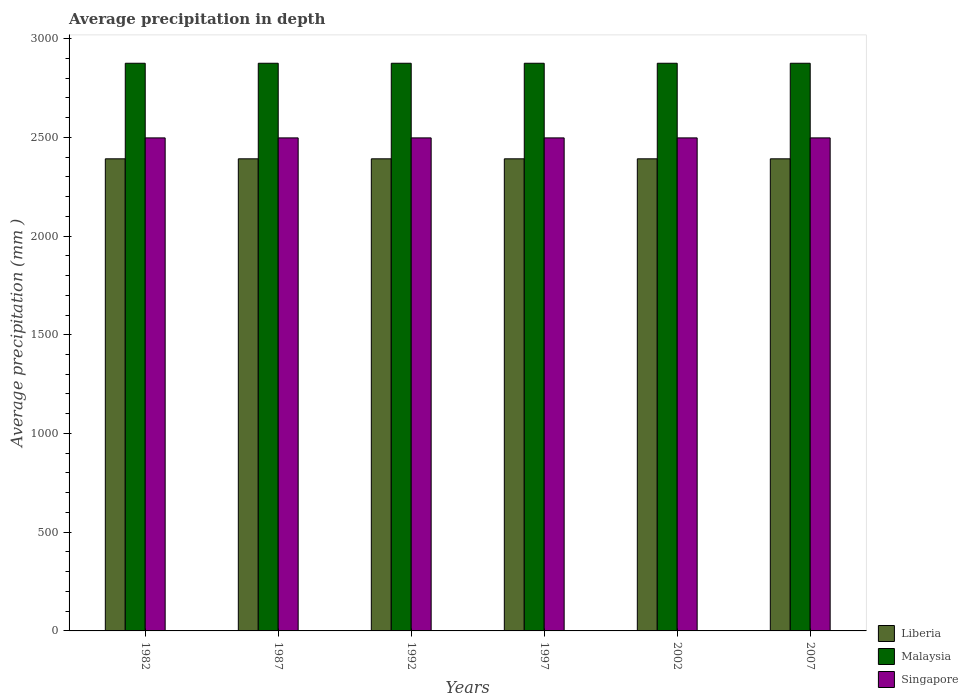How many bars are there on the 2nd tick from the left?
Your response must be concise. 3. What is the label of the 2nd group of bars from the left?
Keep it short and to the point. 1987. What is the average precipitation in Singapore in 2002?
Keep it short and to the point. 2497. Across all years, what is the maximum average precipitation in Malaysia?
Your answer should be compact. 2875. Across all years, what is the minimum average precipitation in Liberia?
Make the answer very short. 2391. In which year was the average precipitation in Singapore maximum?
Provide a short and direct response. 1982. In which year was the average precipitation in Malaysia minimum?
Offer a very short reply. 1982. What is the total average precipitation in Singapore in the graph?
Give a very brief answer. 1.50e+04. What is the difference between the average precipitation in Malaysia in 1982 and that in 1992?
Your response must be concise. 0. What is the difference between the average precipitation in Singapore in 1997 and the average precipitation in Liberia in 2002?
Ensure brevity in your answer.  106. What is the average average precipitation in Malaysia per year?
Ensure brevity in your answer.  2875. In the year 1982, what is the difference between the average precipitation in Singapore and average precipitation in Liberia?
Offer a very short reply. 106. What is the difference between the highest and the second highest average precipitation in Liberia?
Provide a short and direct response. 0. What is the difference between the highest and the lowest average precipitation in Singapore?
Your answer should be compact. 0. In how many years, is the average precipitation in Malaysia greater than the average average precipitation in Malaysia taken over all years?
Your answer should be compact. 0. Is the sum of the average precipitation in Singapore in 1987 and 2002 greater than the maximum average precipitation in Malaysia across all years?
Make the answer very short. Yes. What does the 2nd bar from the left in 1992 represents?
Your answer should be compact. Malaysia. What does the 3rd bar from the right in 1987 represents?
Ensure brevity in your answer.  Liberia. Is it the case that in every year, the sum of the average precipitation in Liberia and average precipitation in Singapore is greater than the average precipitation in Malaysia?
Keep it short and to the point. Yes. How many bars are there?
Make the answer very short. 18. Are all the bars in the graph horizontal?
Provide a short and direct response. No. How many years are there in the graph?
Your answer should be very brief. 6. What is the difference between two consecutive major ticks on the Y-axis?
Offer a terse response. 500. What is the title of the graph?
Your response must be concise. Average precipitation in depth. What is the label or title of the X-axis?
Provide a short and direct response. Years. What is the label or title of the Y-axis?
Offer a terse response. Average precipitation (mm ). What is the Average precipitation (mm ) of Liberia in 1982?
Your answer should be compact. 2391. What is the Average precipitation (mm ) in Malaysia in 1982?
Ensure brevity in your answer.  2875. What is the Average precipitation (mm ) in Singapore in 1982?
Ensure brevity in your answer.  2497. What is the Average precipitation (mm ) of Liberia in 1987?
Offer a terse response. 2391. What is the Average precipitation (mm ) of Malaysia in 1987?
Offer a terse response. 2875. What is the Average precipitation (mm ) in Singapore in 1987?
Give a very brief answer. 2497. What is the Average precipitation (mm ) in Liberia in 1992?
Offer a terse response. 2391. What is the Average precipitation (mm ) of Malaysia in 1992?
Your answer should be compact. 2875. What is the Average precipitation (mm ) in Singapore in 1992?
Offer a terse response. 2497. What is the Average precipitation (mm ) of Liberia in 1997?
Make the answer very short. 2391. What is the Average precipitation (mm ) of Malaysia in 1997?
Make the answer very short. 2875. What is the Average precipitation (mm ) in Singapore in 1997?
Offer a very short reply. 2497. What is the Average precipitation (mm ) in Liberia in 2002?
Provide a succinct answer. 2391. What is the Average precipitation (mm ) of Malaysia in 2002?
Your answer should be compact. 2875. What is the Average precipitation (mm ) of Singapore in 2002?
Ensure brevity in your answer.  2497. What is the Average precipitation (mm ) of Liberia in 2007?
Provide a succinct answer. 2391. What is the Average precipitation (mm ) of Malaysia in 2007?
Your answer should be very brief. 2875. What is the Average precipitation (mm ) of Singapore in 2007?
Make the answer very short. 2497. Across all years, what is the maximum Average precipitation (mm ) of Liberia?
Your response must be concise. 2391. Across all years, what is the maximum Average precipitation (mm ) of Malaysia?
Make the answer very short. 2875. Across all years, what is the maximum Average precipitation (mm ) of Singapore?
Your answer should be very brief. 2497. Across all years, what is the minimum Average precipitation (mm ) in Liberia?
Keep it short and to the point. 2391. Across all years, what is the minimum Average precipitation (mm ) of Malaysia?
Your answer should be compact. 2875. Across all years, what is the minimum Average precipitation (mm ) of Singapore?
Offer a terse response. 2497. What is the total Average precipitation (mm ) in Liberia in the graph?
Your answer should be very brief. 1.43e+04. What is the total Average precipitation (mm ) of Malaysia in the graph?
Your answer should be very brief. 1.72e+04. What is the total Average precipitation (mm ) of Singapore in the graph?
Your response must be concise. 1.50e+04. What is the difference between the Average precipitation (mm ) in Liberia in 1982 and that in 1987?
Keep it short and to the point. 0. What is the difference between the Average precipitation (mm ) of Malaysia in 1982 and that in 1987?
Your answer should be very brief. 0. What is the difference between the Average precipitation (mm ) in Singapore in 1982 and that in 1987?
Your answer should be compact. 0. What is the difference between the Average precipitation (mm ) of Malaysia in 1982 and that in 1992?
Keep it short and to the point. 0. What is the difference between the Average precipitation (mm ) in Liberia in 1982 and that in 1997?
Provide a short and direct response. 0. What is the difference between the Average precipitation (mm ) in Singapore in 1982 and that in 1997?
Make the answer very short. 0. What is the difference between the Average precipitation (mm ) of Liberia in 1982 and that in 2002?
Ensure brevity in your answer.  0. What is the difference between the Average precipitation (mm ) in Liberia in 1982 and that in 2007?
Make the answer very short. 0. What is the difference between the Average precipitation (mm ) of Malaysia in 1982 and that in 2007?
Your answer should be compact. 0. What is the difference between the Average precipitation (mm ) in Singapore in 1982 and that in 2007?
Your response must be concise. 0. What is the difference between the Average precipitation (mm ) in Singapore in 1987 and that in 1992?
Keep it short and to the point. 0. What is the difference between the Average precipitation (mm ) of Liberia in 1987 and that in 1997?
Offer a terse response. 0. What is the difference between the Average precipitation (mm ) in Malaysia in 1987 and that in 1997?
Provide a succinct answer. 0. What is the difference between the Average precipitation (mm ) of Liberia in 1987 and that in 2002?
Your answer should be very brief. 0. What is the difference between the Average precipitation (mm ) of Singapore in 1987 and that in 2002?
Provide a short and direct response. 0. What is the difference between the Average precipitation (mm ) of Singapore in 1987 and that in 2007?
Your response must be concise. 0. What is the difference between the Average precipitation (mm ) in Malaysia in 1992 and that in 1997?
Keep it short and to the point. 0. What is the difference between the Average precipitation (mm ) in Singapore in 1992 and that in 1997?
Give a very brief answer. 0. What is the difference between the Average precipitation (mm ) in Liberia in 1992 and that in 2002?
Offer a very short reply. 0. What is the difference between the Average precipitation (mm ) in Singapore in 1992 and that in 2002?
Your response must be concise. 0. What is the difference between the Average precipitation (mm ) in Singapore in 1997 and that in 2002?
Provide a short and direct response. 0. What is the difference between the Average precipitation (mm ) in Malaysia in 1997 and that in 2007?
Give a very brief answer. 0. What is the difference between the Average precipitation (mm ) in Singapore in 1997 and that in 2007?
Offer a terse response. 0. What is the difference between the Average precipitation (mm ) of Malaysia in 2002 and that in 2007?
Your response must be concise. 0. What is the difference between the Average precipitation (mm ) of Singapore in 2002 and that in 2007?
Ensure brevity in your answer.  0. What is the difference between the Average precipitation (mm ) of Liberia in 1982 and the Average precipitation (mm ) of Malaysia in 1987?
Keep it short and to the point. -484. What is the difference between the Average precipitation (mm ) of Liberia in 1982 and the Average precipitation (mm ) of Singapore in 1987?
Offer a very short reply. -106. What is the difference between the Average precipitation (mm ) of Malaysia in 1982 and the Average precipitation (mm ) of Singapore in 1987?
Provide a succinct answer. 378. What is the difference between the Average precipitation (mm ) in Liberia in 1982 and the Average precipitation (mm ) in Malaysia in 1992?
Keep it short and to the point. -484. What is the difference between the Average precipitation (mm ) in Liberia in 1982 and the Average precipitation (mm ) in Singapore in 1992?
Ensure brevity in your answer.  -106. What is the difference between the Average precipitation (mm ) of Malaysia in 1982 and the Average precipitation (mm ) of Singapore in 1992?
Your answer should be compact. 378. What is the difference between the Average precipitation (mm ) in Liberia in 1982 and the Average precipitation (mm ) in Malaysia in 1997?
Make the answer very short. -484. What is the difference between the Average precipitation (mm ) in Liberia in 1982 and the Average precipitation (mm ) in Singapore in 1997?
Your answer should be very brief. -106. What is the difference between the Average precipitation (mm ) of Malaysia in 1982 and the Average precipitation (mm ) of Singapore in 1997?
Make the answer very short. 378. What is the difference between the Average precipitation (mm ) in Liberia in 1982 and the Average precipitation (mm ) in Malaysia in 2002?
Your response must be concise. -484. What is the difference between the Average precipitation (mm ) of Liberia in 1982 and the Average precipitation (mm ) of Singapore in 2002?
Provide a succinct answer. -106. What is the difference between the Average precipitation (mm ) in Malaysia in 1982 and the Average precipitation (mm ) in Singapore in 2002?
Provide a short and direct response. 378. What is the difference between the Average precipitation (mm ) of Liberia in 1982 and the Average precipitation (mm ) of Malaysia in 2007?
Offer a very short reply. -484. What is the difference between the Average precipitation (mm ) of Liberia in 1982 and the Average precipitation (mm ) of Singapore in 2007?
Provide a succinct answer. -106. What is the difference between the Average precipitation (mm ) in Malaysia in 1982 and the Average precipitation (mm ) in Singapore in 2007?
Offer a very short reply. 378. What is the difference between the Average precipitation (mm ) in Liberia in 1987 and the Average precipitation (mm ) in Malaysia in 1992?
Your answer should be compact. -484. What is the difference between the Average precipitation (mm ) of Liberia in 1987 and the Average precipitation (mm ) of Singapore in 1992?
Keep it short and to the point. -106. What is the difference between the Average precipitation (mm ) of Malaysia in 1987 and the Average precipitation (mm ) of Singapore in 1992?
Keep it short and to the point. 378. What is the difference between the Average precipitation (mm ) of Liberia in 1987 and the Average precipitation (mm ) of Malaysia in 1997?
Provide a succinct answer. -484. What is the difference between the Average precipitation (mm ) of Liberia in 1987 and the Average precipitation (mm ) of Singapore in 1997?
Your answer should be compact. -106. What is the difference between the Average precipitation (mm ) of Malaysia in 1987 and the Average precipitation (mm ) of Singapore in 1997?
Keep it short and to the point. 378. What is the difference between the Average precipitation (mm ) of Liberia in 1987 and the Average precipitation (mm ) of Malaysia in 2002?
Your answer should be very brief. -484. What is the difference between the Average precipitation (mm ) in Liberia in 1987 and the Average precipitation (mm ) in Singapore in 2002?
Keep it short and to the point. -106. What is the difference between the Average precipitation (mm ) in Malaysia in 1987 and the Average precipitation (mm ) in Singapore in 2002?
Provide a succinct answer. 378. What is the difference between the Average precipitation (mm ) in Liberia in 1987 and the Average precipitation (mm ) in Malaysia in 2007?
Your response must be concise. -484. What is the difference between the Average precipitation (mm ) of Liberia in 1987 and the Average precipitation (mm ) of Singapore in 2007?
Provide a succinct answer. -106. What is the difference between the Average precipitation (mm ) in Malaysia in 1987 and the Average precipitation (mm ) in Singapore in 2007?
Make the answer very short. 378. What is the difference between the Average precipitation (mm ) of Liberia in 1992 and the Average precipitation (mm ) of Malaysia in 1997?
Provide a short and direct response. -484. What is the difference between the Average precipitation (mm ) of Liberia in 1992 and the Average precipitation (mm ) of Singapore in 1997?
Keep it short and to the point. -106. What is the difference between the Average precipitation (mm ) of Malaysia in 1992 and the Average precipitation (mm ) of Singapore in 1997?
Your answer should be very brief. 378. What is the difference between the Average precipitation (mm ) of Liberia in 1992 and the Average precipitation (mm ) of Malaysia in 2002?
Your response must be concise. -484. What is the difference between the Average precipitation (mm ) of Liberia in 1992 and the Average precipitation (mm ) of Singapore in 2002?
Make the answer very short. -106. What is the difference between the Average precipitation (mm ) in Malaysia in 1992 and the Average precipitation (mm ) in Singapore in 2002?
Offer a very short reply. 378. What is the difference between the Average precipitation (mm ) of Liberia in 1992 and the Average precipitation (mm ) of Malaysia in 2007?
Give a very brief answer. -484. What is the difference between the Average precipitation (mm ) of Liberia in 1992 and the Average precipitation (mm ) of Singapore in 2007?
Ensure brevity in your answer.  -106. What is the difference between the Average precipitation (mm ) in Malaysia in 1992 and the Average precipitation (mm ) in Singapore in 2007?
Give a very brief answer. 378. What is the difference between the Average precipitation (mm ) of Liberia in 1997 and the Average precipitation (mm ) of Malaysia in 2002?
Offer a terse response. -484. What is the difference between the Average precipitation (mm ) of Liberia in 1997 and the Average precipitation (mm ) of Singapore in 2002?
Your answer should be compact. -106. What is the difference between the Average precipitation (mm ) of Malaysia in 1997 and the Average precipitation (mm ) of Singapore in 2002?
Your answer should be very brief. 378. What is the difference between the Average precipitation (mm ) in Liberia in 1997 and the Average precipitation (mm ) in Malaysia in 2007?
Your answer should be compact. -484. What is the difference between the Average precipitation (mm ) in Liberia in 1997 and the Average precipitation (mm ) in Singapore in 2007?
Your answer should be very brief. -106. What is the difference between the Average precipitation (mm ) in Malaysia in 1997 and the Average precipitation (mm ) in Singapore in 2007?
Provide a succinct answer. 378. What is the difference between the Average precipitation (mm ) of Liberia in 2002 and the Average precipitation (mm ) of Malaysia in 2007?
Give a very brief answer. -484. What is the difference between the Average precipitation (mm ) in Liberia in 2002 and the Average precipitation (mm ) in Singapore in 2007?
Ensure brevity in your answer.  -106. What is the difference between the Average precipitation (mm ) of Malaysia in 2002 and the Average precipitation (mm ) of Singapore in 2007?
Your answer should be compact. 378. What is the average Average precipitation (mm ) in Liberia per year?
Your response must be concise. 2391. What is the average Average precipitation (mm ) of Malaysia per year?
Offer a terse response. 2875. What is the average Average precipitation (mm ) in Singapore per year?
Ensure brevity in your answer.  2497. In the year 1982, what is the difference between the Average precipitation (mm ) in Liberia and Average precipitation (mm ) in Malaysia?
Provide a short and direct response. -484. In the year 1982, what is the difference between the Average precipitation (mm ) of Liberia and Average precipitation (mm ) of Singapore?
Your answer should be very brief. -106. In the year 1982, what is the difference between the Average precipitation (mm ) in Malaysia and Average precipitation (mm ) in Singapore?
Make the answer very short. 378. In the year 1987, what is the difference between the Average precipitation (mm ) of Liberia and Average precipitation (mm ) of Malaysia?
Provide a short and direct response. -484. In the year 1987, what is the difference between the Average precipitation (mm ) of Liberia and Average precipitation (mm ) of Singapore?
Provide a succinct answer. -106. In the year 1987, what is the difference between the Average precipitation (mm ) in Malaysia and Average precipitation (mm ) in Singapore?
Keep it short and to the point. 378. In the year 1992, what is the difference between the Average precipitation (mm ) of Liberia and Average precipitation (mm ) of Malaysia?
Ensure brevity in your answer.  -484. In the year 1992, what is the difference between the Average precipitation (mm ) in Liberia and Average precipitation (mm ) in Singapore?
Provide a short and direct response. -106. In the year 1992, what is the difference between the Average precipitation (mm ) of Malaysia and Average precipitation (mm ) of Singapore?
Offer a very short reply. 378. In the year 1997, what is the difference between the Average precipitation (mm ) in Liberia and Average precipitation (mm ) in Malaysia?
Provide a short and direct response. -484. In the year 1997, what is the difference between the Average precipitation (mm ) in Liberia and Average precipitation (mm ) in Singapore?
Your answer should be very brief. -106. In the year 1997, what is the difference between the Average precipitation (mm ) in Malaysia and Average precipitation (mm ) in Singapore?
Offer a terse response. 378. In the year 2002, what is the difference between the Average precipitation (mm ) of Liberia and Average precipitation (mm ) of Malaysia?
Your answer should be very brief. -484. In the year 2002, what is the difference between the Average precipitation (mm ) in Liberia and Average precipitation (mm ) in Singapore?
Offer a terse response. -106. In the year 2002, what is the difference between the Average precipitation (mm ) of Malaysia and Average precipitation (mm ) of Singapore?
Ensure brevity in your answer.  378. In the year 2007, what is the difference between the Average precipitation (mm ) in Liberia and Average precipitation (mm ) in Malaysia?
Provide a succinct answer. -484. In the year 2007, what is the difference between the Average precipitation (mm ) in Liberia and Average precipitation (mm ) in Singapore?
Your answer should be compact. -106. In the year 2007, what is the difference between the Average precipitation (mm ) of Malaysia and Average precipitation (mm ) of Singapore?
Provide a succinct answer. 378. What is the ratio of the Average precipitation (mm ) in Liberia in 1982 to that in 1987?
Provide a short and direct response. 1. What is the ratio of the Average precipitation (mm ) in Malaysia in 1982 to that in 1987?
Your response must be concise. 1. What is the ratio of the Average precipitation (mm ) in Singapore in 1982 to that in 1987?
Make the answer very short. 1. What is the ratio of the Average precipitation (mm ) of Liberia in 1982 to that in 1992?
Keep it short and to the point. 1. What is the ratio of the Average precipitation (mm ) of Malaysia in 1982 to that in 1992?
Provide a short and direct response. 1. What is the ratio of the Average precipitation (mm ) in Singapore in 1982 to that in 1992?
Keep it short and to the point. 1. What is the ratio of the Average precipitation (mm ) of Liberia in 1982 to that in 1997?
Your answer should be compact. 1. What is the ratio of the Average precipitation (mm ) in Malaysia in 1982 to that in 1997?
Offer a terse response. 1. What is the ratio of the Average precipitation (mm ) in Malaysia in 1982 to that in 2002?
Your response must be concise. 1. What is the ratio of the Average precipitation (mm ) of Singapore in 1982 to that in 2002?
Your response must be concise. 1. What is the ratio of the Average precipitation (mm ) in Singapore in 1982 to that in 2007?
Offer a terse response. 1. What is the ratio of the Average precipitation (mm ) of Malaysia in 1987 to that in 1992?
Give a very brief answer. 1. What is the ratio of the Average precipitation (mm ) in Singapore in 1987 to that in 1992?
Provide a succinct answer. 1. What is the ratio of the Average precipitation (mm ) of Liberia in 1987 to that in 1997?
Provide a short and direct response. 1. What is the ratio of the Average precipitation (mm ) of Malaysia in 1987 to that in 2002?
Your answer should be compact. 1. What is the ratio of the Average precipitation (mm ) of Singapore in 1987 to that in 2002?
Give a very brief answer. 1. What is the ratio of the Average precipitation (mm ) of Liberia in 1987 to that in 2007?
Keep it short and to the point. 1. What is the ratio of the Average precipitation (mm ) in Liberia in 1992 to that in 1997?
Your answer should be compact. 1. What is the ratio of the Average precipitation (mm ) in Singapore in 1992 to that in 2002?
Your answer should be very brief. 1. What is the ratio of the Average precipitation (mm ) of Liberia in 1992 to that in 2007?
Ensure brevity in your answer.  1. What is the ratio of the Average precipitation (mm ) of Malaysia in 1992 to that in 2007?
Your answer should be compact. 1. What is the ratio of the Average precipitation (mm ) in Singapore in 1997 to that in 2002?
Your answer should be very brief. 1. What is the ratio of the Average precipitation (mm ) of Liberia in 1997 to that in 2007?
Offer a very short reply. 1. What is the difference between the highest and the second highest Average precipitation (mm ) in Liberia?
Provide a succinct answer. 0. What is the difference between the highest and the second highest Average precipitation (mm ) of Malaysia?
Offer a very short reply. 0. What is the difference between the highest and the second highest Average precipitation (mm ) of Singapore?
Provide a short and direct response. 0. What is the difference between the highest and the lowest Average precipitation (mm ) in Malaysia?
Provide a succinct answer. 0. 